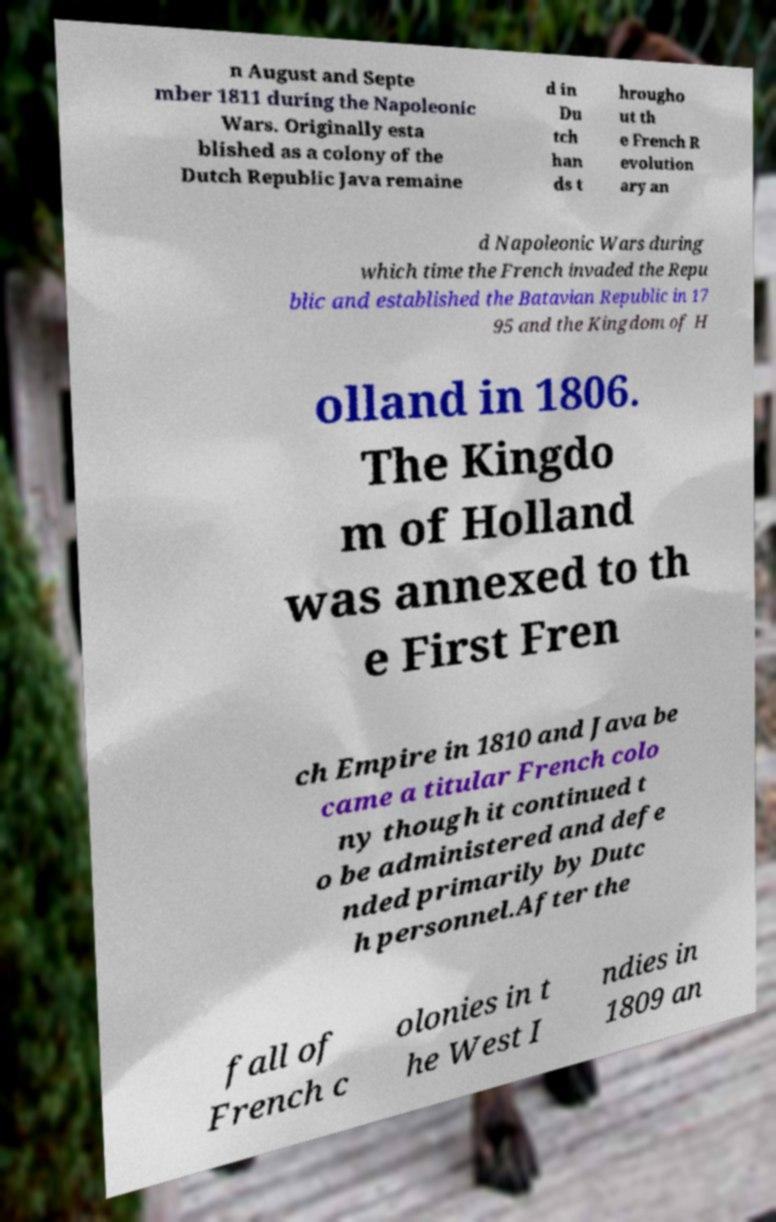Please read and relay the text visible in this image. What does it say? n August and Septe mber 1811 during the Napoleonic Wars. Originally esta blished as a colony of the Dutch Republic Java remaine d in Du tch han ds t hrougho ut th e French R evolution ary an d Napoleonic Wars during which time the French invaded the Repu blic and established the Batavian Republic in 17 95 and the Kingdom of H olland in 1806. The Kingdo m of Holland was annexed to th e First Fren ch Empire in 1810 and Java be came a titular French colo ny though it continued t o be administered and defe nded primarily by Dutc h personnel.After the fall of French c olonies in t he West I ndies in 1809 an 